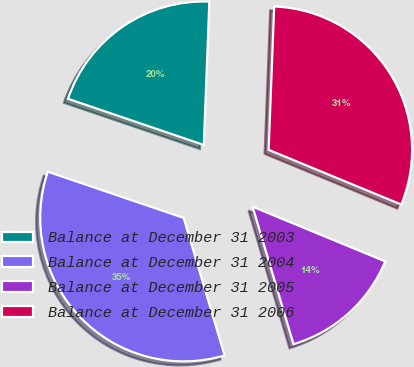Convert chart. <chart><loc_0><loc_0><loc_500><loc_500><pie_chart><fcel>Balance at December 31 2003<fcel>Balance at December 31 2004<fcel>Balance at December 31 2005<fcel>Balance at December 31 2006<nl><fcel>20.4%<fcel>34.82%<fcel>14.17%<fcel>30.61%<nl></chart> 